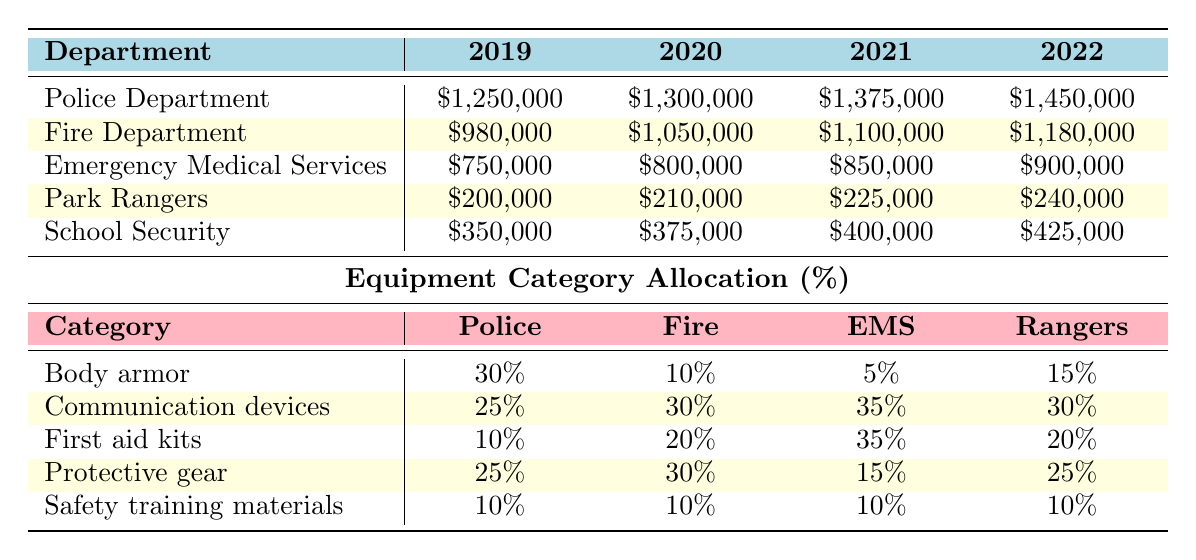What was the budget for the Fire Department in 2021? The table displays the budget for the Fire Department specifically for each year listed. In the year 2021, the budget is directly shown as \$1,100,000.
Answer: \$1,100,000 Which department received the highest budget in 2022? By looking at the table, we can see the budgets for each department in 2022. The Police Department has the highest budget of \$1,450,000 compared to the others.
Answer: Police Department What is the total budget for Emergency Medical Services from 2019 to 2022? To find the total budget for the Emergency Medical Services across the years, we add the four yearly budgets: \$750,000 + \$800,000 + \$850,000 + \$900,000 = \$3,300,000.
Answer: \$3,300,000 Did the Park Rangers’ budget increase every year from 2019 to 2022? By examining the annual budgets for Park Rangers from 2019 to 2022, we can see the values: \$200,000, \$210,000, \$225,000, and \$240,000. Each value is greater than the previous year, confirming the budget increased every year.
Answer: Yes What percentage of the total budget in 2020 was allocated to Body armor for the Police Department? First, we find out the total 2020 budget for the Police Department, which is \$1,300,000. The allocation for Body armor is 30%. To find the dollar amount, we calculate 30% of \$1,300,000: 0.30 x \$1,300,000 = \$390,000.
Answer: \$390,000 Which department allocated the highest percentage to Communication devices? The table shows that Emergency Medical Services allocated 35% of their budget towards Communication devices, which is the highest percentage among all departments.
Answer: Emergency Medical Services What is the average yearly budget for School Security from 2019 to 2022? To calculate the average, we need to sum the yearly budgets: \$350,000 + \$375,000 + \$400,000 + \$425,000 = \$1,550,000. Then, we divide by the number of years (4): \$1,550,000 / 4 = \$387,500.
Answer: \$387,500 Is the allocation for Safety training materials equal across all departments? The table shows that the allocation percentage for Safety training materials is 10% for all departments, indicating that it is equal across all departments.
Answer: Yes What is the difference in budget between the Police Department and the Fire Department for 2022? The Police Department's budget for 2022 is \$1,450,000 and the Fire Department's is \$1,180,000. The difference is \$1,450,000 - \$1,180,000 = \$270,000.
Answer: \$270,000 What was the total percentage allocated to Protective gear across all departments? We can add the percentages allocated to Protective gear from each department: 25% (Police) + 30% (Fire) + 15% (EMS) + 25% (Rangers) + 20% (School Security) = 125%.
Answer: 125% 